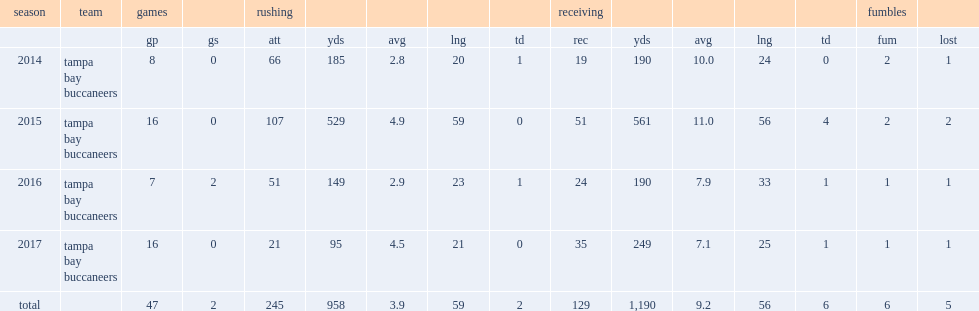In 2016 season, how many rushes did charles sims finish for 149 yards? 51.0. 